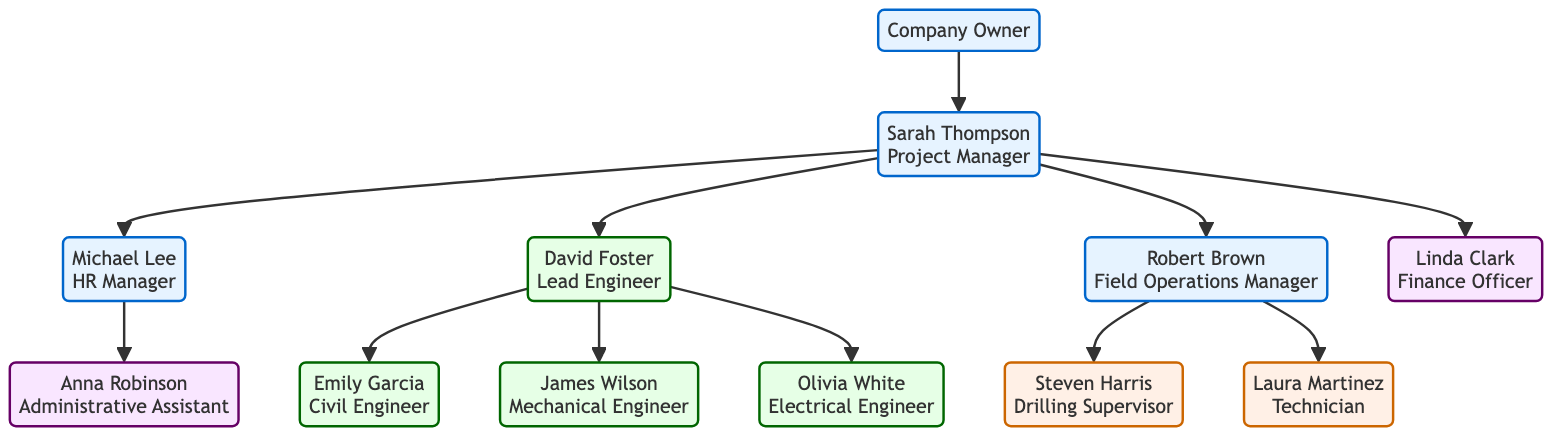What is the name of the Project Manager? The diagram indicates the Project Manager's name is Sarah Thompson, as represented at that specific node in the hierarchy.
Answer: Sarah Thompson How many engineers are under the Lead Engineer? The diagram shows that there are three engineers (Civil Engineer, Mechanical Engineer, Electrical Engineer) who report to the Lead Engineer, David Foster.
Answer: 3 Who manages recruitment and training? According to the diagram, the HR Manager, Michael Lee, is responsible for managing recruitment, training, and employee relations, as stated in his role description.
Answer: Michael Lee Which engineer is responsible for electrical systems? The diagram states that Olivia White is the Electrical Engineer, who manages electrical systems and connections, as indicated at her node.
Answer: Olivia White Who directly reports to the Project Manager besides the HR Manager? The diagram shows that the Field Operations Manager (Robert Brown) and the Finance Officer (Linda Clark) also report to the Project Manager, alongside the HR Manager. Therefore, there are two additional staff members in this category.
Answer: 2 What role does the Administrative Assistant play? The diagram specifies that Anna Robinson functions as the Administrative Assistant, providing administrative support to the HR Manager. This role is clearly outlined in her entry.
Answer: Administrative Assistant Which role has a direct line to the Field Operations Manager? The diagram highlights that both the Drilling Supervisor (Steven Harris) and the Technician (Laura Martinez) report directly to the Field Operations Manager, Robert Brown.
Answer: 2 Who oversees drilling operations? According to the diagram, the Drilling Supervisor, Steven Harris, is tasked with overseeing drilling operations and maintaining safety protocols, as specified at his node.
Answer: Steven Harris What is the role of the Finance Officer? The diagram reveals that Linda Clark, as the Finance Officer, is responsible for managing project budgets and financial planning, as described in her role.
Answer: Manage project budgets and financial planning 